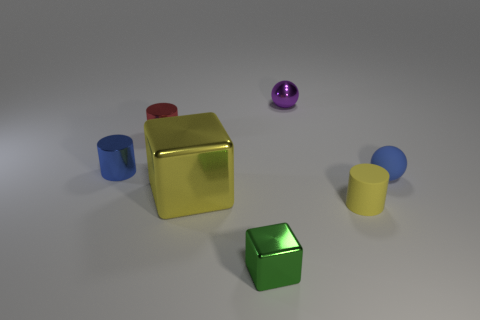Subtract all tiny yellow matte cylinders. How many cylinders are left? 2 Subtract 1 cylinders. How many cylinders are left? 2 Add 1 small red objects. How many objects exist? 8 Add 3 blue cylinders. How many blue cylinders exist? 4 Subtract 0 green spheres. How many objects are left? 7 Subtract all blocks. How many objects are left? 5 Subtract all purple cylinders. Subtract all yellow balls. How many cylinders are left? 3 Subtract all cyan shiny cylinders. Subtract all small blue metal cylinders. How many objects are left? 6 Add 2 tiny blue spheres. How many tiny blue spheres are left? 3 